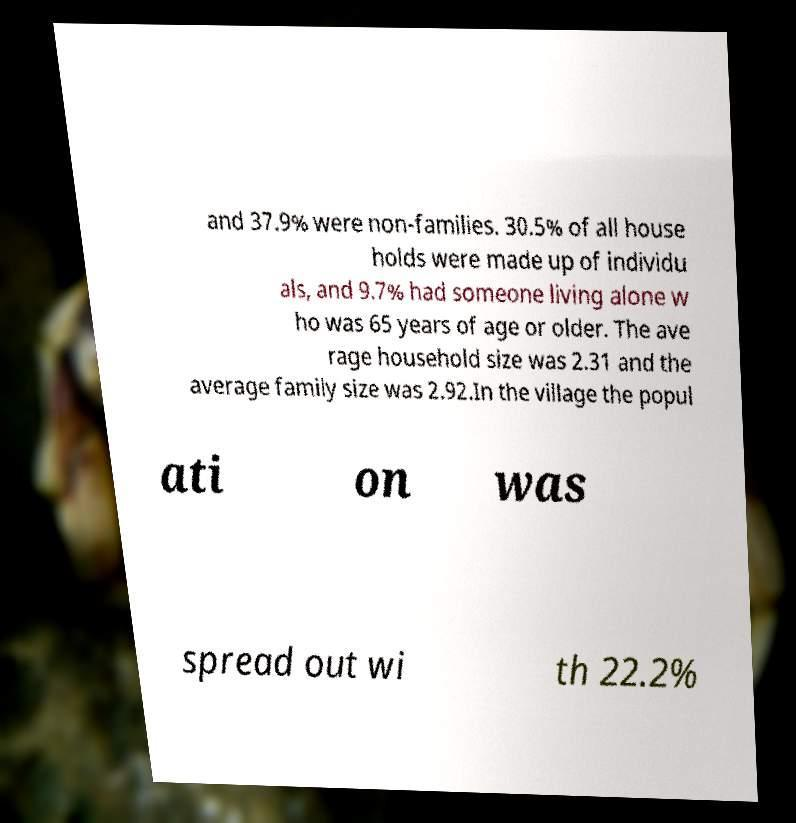Please read and relay the text visible in this image. What does it say? and 37.9% were non-families. 30.5% of all house holds were made up of individu als, and 9.7% had someone living alone w ho was 65 years of age or older. The ave rage household size was 2.31 and the average family size was 2.92.In the village the popul ati on was spread out wi th 22.2% 